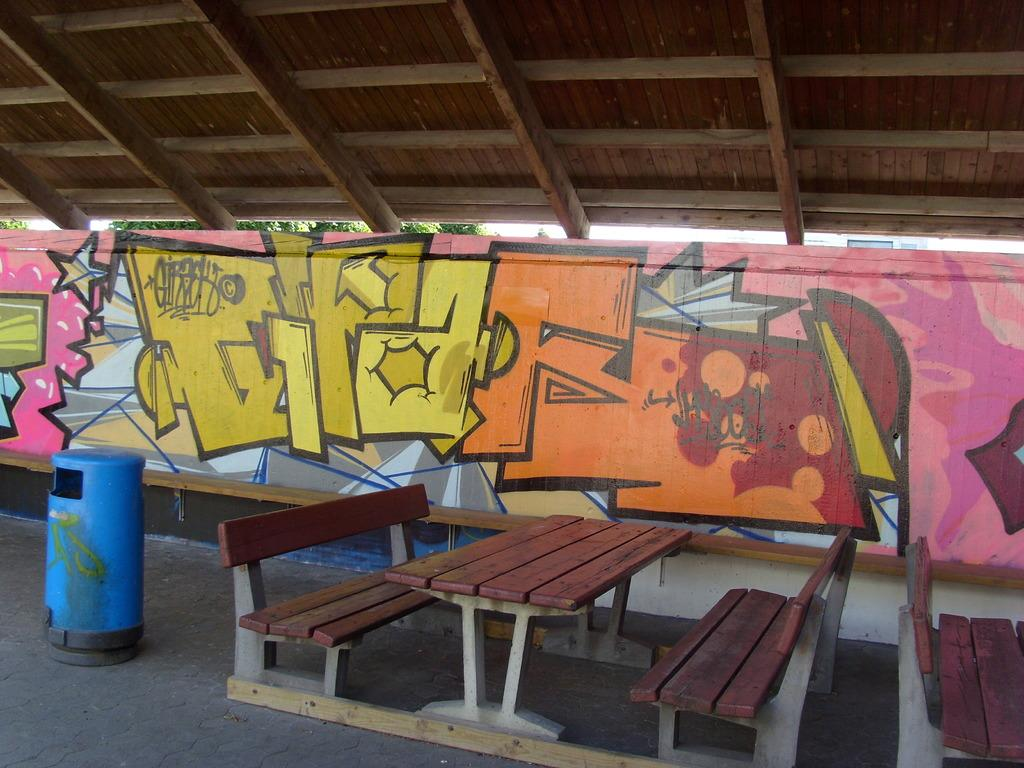What type of furniture is located in the center of the image? There is a bench and table in the center of the image. Where is the dustbin positioned in the image? The dustbin is on the left side of the image. What can be seen in the background of the image? There is a shutter visible in the background of the image. What type of tax is being discussed in the image? There is no discussion of tax in the image; it features a bench, table, dustbin, and shutter. Can you see an aunt in the image? There is no aunt present in the image. 